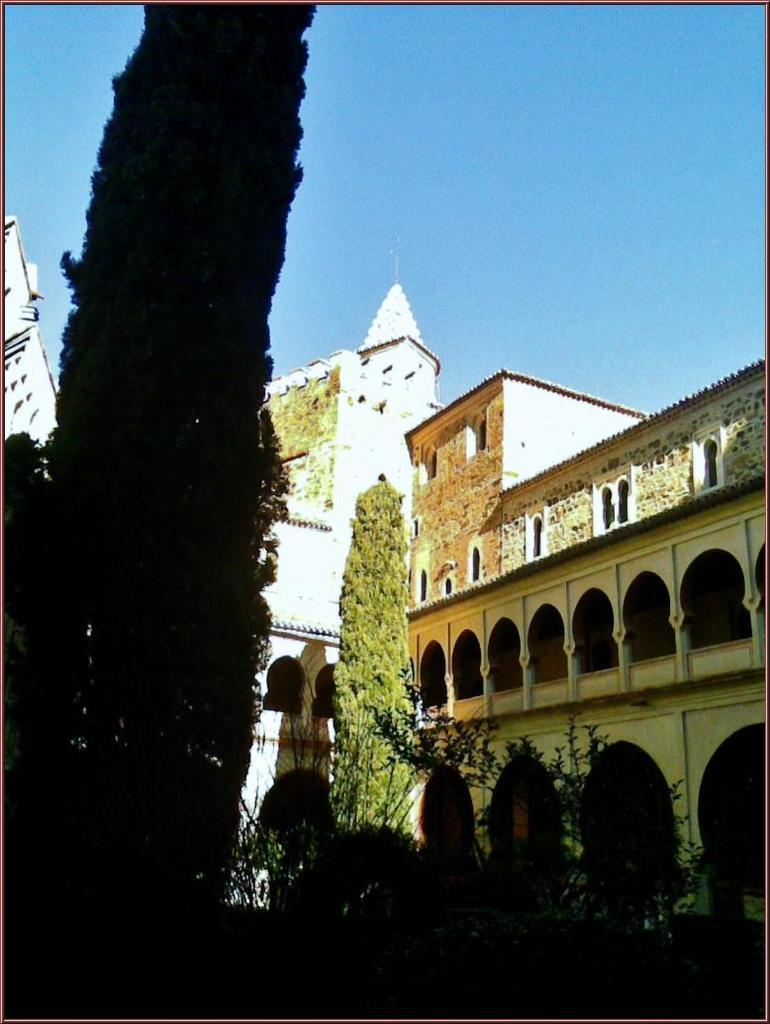What type of natural elements can be seen in the image? There are trees and plants in the image. What type of man-made structures are present in the image? There are buildings in the image. What part of the natural environment is visible in the image? The sky is visible in the image. What type of substance is being transported in the crate in the image? There is no crate present in the image, so it is not possible to determine what, if any, substance might be transported. 